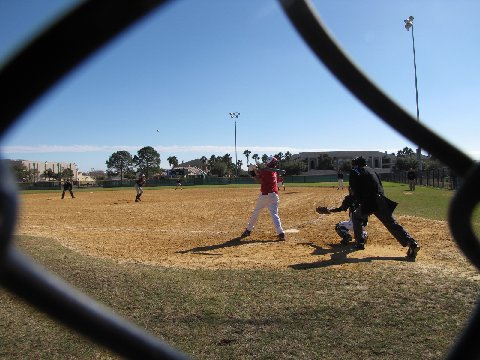What type of baseball game is being played in the image? The image captures the heartwarming essence of a little league baseball game, where young aspirants, possibly between the ages of 7 and 13, are donning their team uniforms and diligently playing the sport, which appears to be set amidst the backdrop of a community field under a clear sky. 